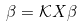Convert formula to latex. <formula><loc_0><loc_0><loc_500><loc_500>\beta = \mathcal { K } X \beta</formula> 